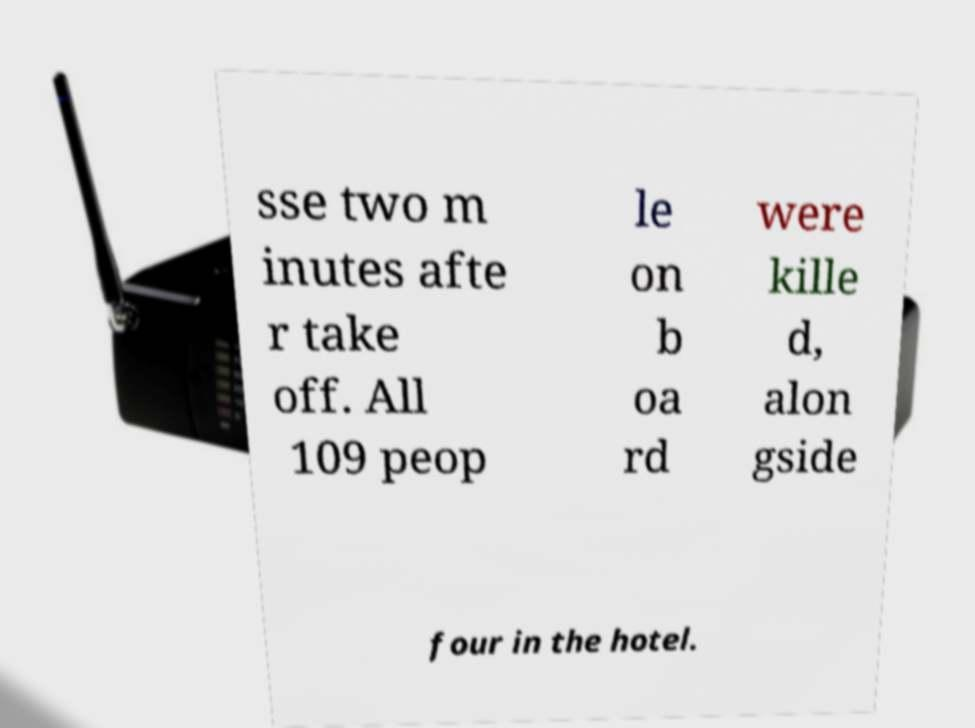Please read and relay the text visible in this image. What does it say? sse two m inutes afte r take off. All 109 peop le on b oa rd were kille d, alon gside four in the hotel. 